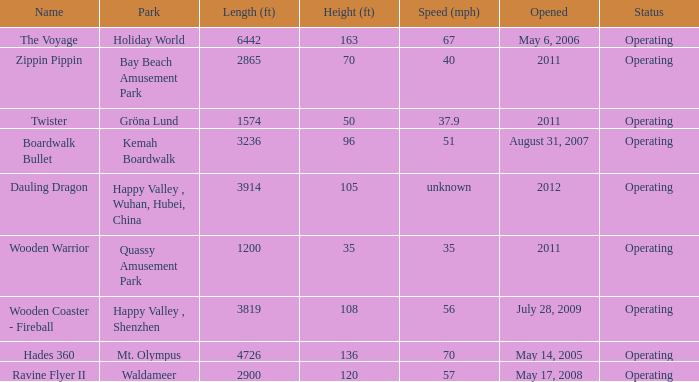How fast is the coaster that is 163 feet tall 67.0. 